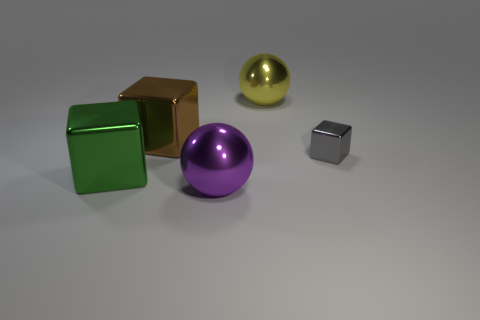Subtract all blue blocks. Subtract all red balls. How many blocks are left? 3 Add 4 tiny gray metallic cubes. How many objects exist? 9 Subtract all spheres. How many objects are left? 3 Add 3 big green cubes. How many big green cubes exist? 4 Subtract 0 purple cubes. How many objects are left? 5 Subtract all big green objects. Subtract all big brown metal cubes. How many objects are left? 3 Add 2 purple objects. How many purple objects are left? 3 